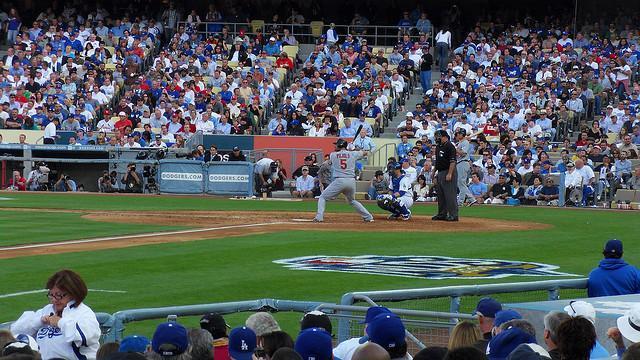How many people can be seen?
Give a very brief answer. 3. How many green bottles are on the table?
Give a very brief answer. 0. 